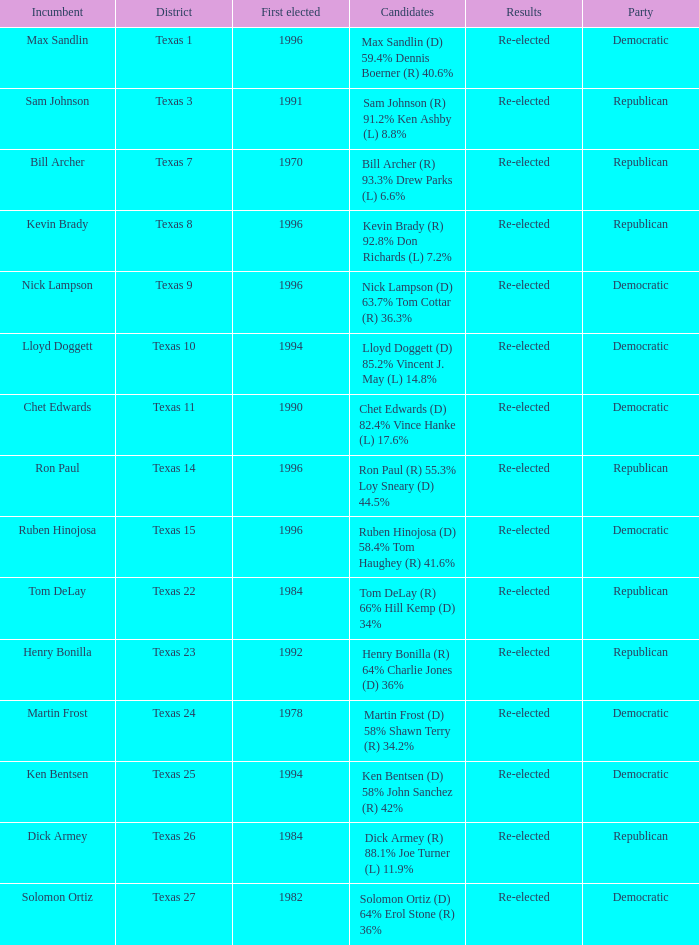What district is nick lampson from? Texas 9. 